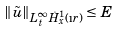Convert formula to latex. <formula><loc_0><loc_0><loc_500><loc_500>\| \tilde { u } \| _ { L ^ { \infty } _ { t } \dot { H } ^ { 1 } _ { x } ( \i r ) } \leq E</formula> 